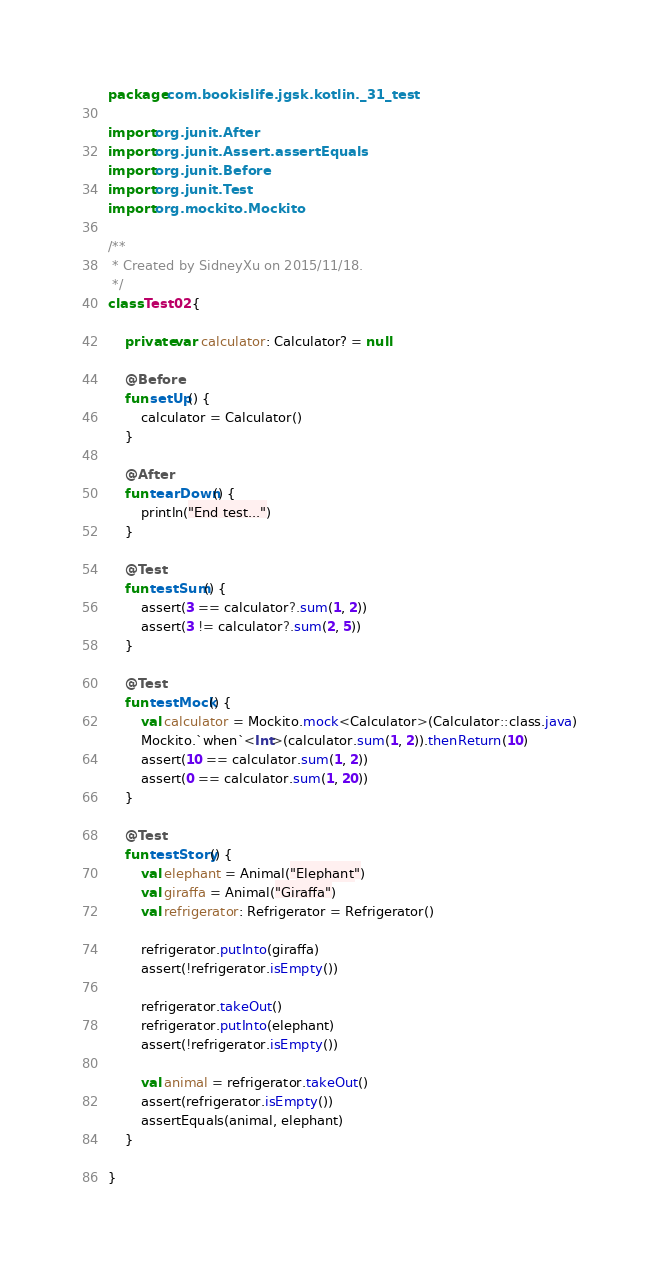<code> <loc_0><loc_0><loc_500><loc_500><_Kotlin_>package com.bookislife.jgsk.kotlin._31_test

import org.junit.After
import org.junit.Assert.assertEquals
import org.junit.Before
import org.junit.Test
import org.mockito.Mockito

/**
 * Created by SidneyXu on 2015/11/18.
 */
class Test02 {

    private var calculator: Calculator? = null

    @Before
    fun setUp() {
        calculator = Calculator()
    }

    @After
    fun tearDown() {
        println("End test...")
    }

    @Test
    fun testSum() {
        assert(3 == calculator?.sum(1, 2))
        assert(3 != calculator?.sum(2, 5))
    }

    @Test
    fun testMock() {
        val calculator = Mockito.mock<Calculator>(Calculator::class.java)
        Mockito.`when`<Int>(calculator.sum(1, 2)).thenReturn(10)
        assert(10 == calculator.sum(1, 2))
        assert(0 == calculator.sum(1, 20))
    }

    @Test
    fun testStory() {
        val elephant = Animal("Elephant")
        val giraffa = Animal("Giraffa")
        val refrigerator: Refrigerator = Refrigerator()

        refrigerator.putInto(giraffa)
        assert(!refrigerator.isEmpty())

        refrigerator.takeOut()
        refrigerator.putInto(elephant)
        assert(!refrigerator.isEmpty())

        val animal = refrigerator.takeOut()
        assert(refrigerator.isEmpty())
        assertEquals(animal, elephant)
    }

}</code> 